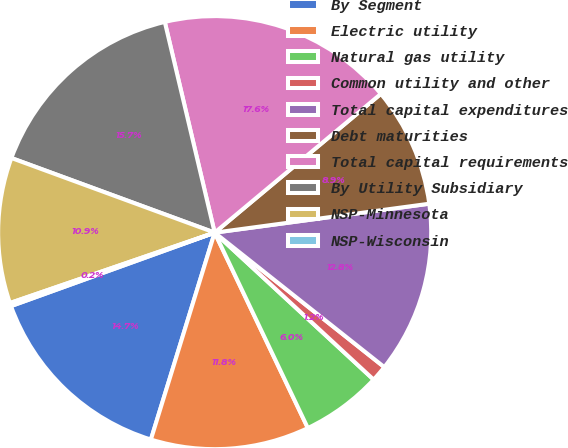<chart> <loc_0><loc_0><loc_500><loc_500><pie_chart><fcel>By Segment<fcel>Electric utility<fcel>Natural gas utility<fcel>Common utility and other<fcel>Total capital expenditures<fcel>Debt maturities<fcel>Total capital requirements<fcel>By Utility Subsidiary<fcel>NSP-Minnesota<fcel>NSP-Wisconsin<nl><fcel>14.73%<fcel>11.84%<fcel>6.04%<fcel>1.21%<fcel>12.8%<fcel>8.94%<fcel>17.63%<fcel>15.7%<fcel>10.87%<fcel>0.24%<nl></chart> 